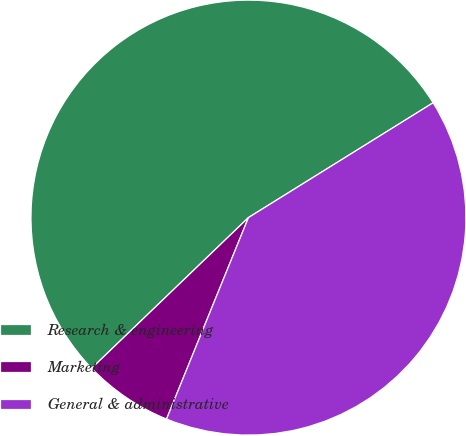<chart> <loc_0><loc_0><loc_500><loc_500><pie_chart><fcel>Research & engineering<fcel>Marketing<fcel>General & administrative<nl><fcel>53.33%<fcel>6.67%<fcel>40.0%<nl></chart> 